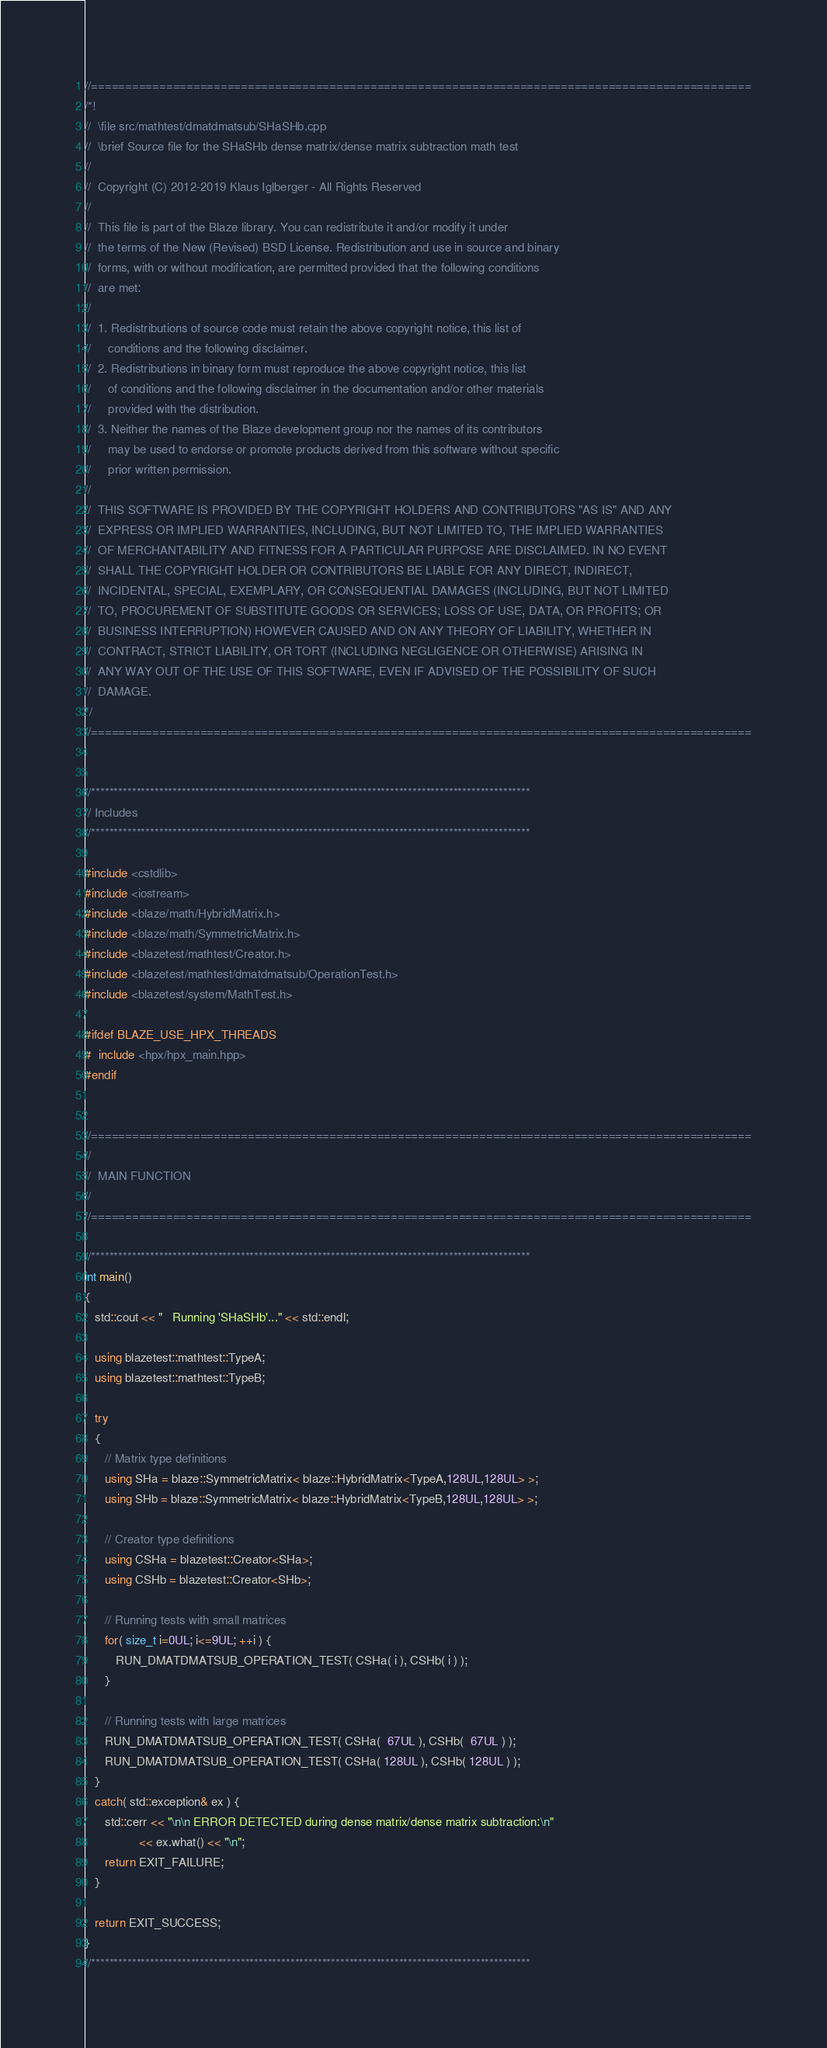Convert code to text. <code><loc_0><loc_0><loc_500><loc_500><_C++_>//=================================================================================================
/*!
//  \file src/mathtest/dmatdmatsub/SHaSHb.cpp
//  \brief Source file for the SHaSHb dense matrix/dense matrix subtraction math test
//
//  Copyright (C) 2012-2019 Klaus Iglberger - All Rights Reserved
//
//  This file is part of the Blaze library. You can redistribute it and/or modify it under
//  the terms of the New (Revised) BSD License. Redistribution and use in source and binary
//  forms, with or without modification, are permitted provided that the following conditions
//  are met:
//
//  1. Redistributions of source code must retain the above copyright notice, this list of
//     conditions and the following disclaimer.
//  2. Redistributions in binary form must reproduce the above copyright notice, this list
//     of conditions and the following disclaimer in the documentation and/or other materials
//     provided with the distribution.
//  3. Neither the names of the Blaze development group nor the names of its contributors
//     may be used to endorse or promote products derived from this software without specific
//     prior written permission.
//
//  THIS SOFTWARE IS PROVIDED BY THE COPYRIGHT HOLDERS AND CONTRIBUTORS "AS IS" AND ANY
//  EXPRESS OR IMPLIED WARRANTIES, INCLUDING, BUT NOT LIMITED TO, THE IMPLIED WARRANTIES
//  OF MERCHANTABILITY AND FITNESS FOR A PARTICULAR PURPOSE ARE DISCLAIMED. IN NO EVENT
//  SHALL THE COPYRIGHT HOLDER OR CONTRIBUTORS BE LIABLE FOR ANY DIRECT, INDIRECT,
//  INCIDENTAL, SPECIAL, EXEMPLARY, OR CONSEQUENTIAL DAMAGES (INCLUDING, BUT NOT LIMITED
//  TO, PROCUREMENT OF SUBSTITUTE GOODS OR SERVICES; LOSS OF USE, DATA, OR PROFITS; OR
//  BUSINESS INTERRUPTION) HOWEVER CAUSED AND ON ANY THEORY OF LIABILITY, WHETHER IN
//  CONTRACT, STRICT LIABILITY, OR TORT (INCLUDING NEGLIGENCE OR OTHERWISE) ARISING IN
//  ANY WAY OUT OF THE USE OF THIS SOFTWARE, EVEN IF ADVISED OF THE POSSIBILITY OF SUCH
//  DAMAGE.
*/
//=================================================================================================


//*************************************************************************************************
// Includes
//*************************************************************************************************

#include <cstdlib>
#include <iostream>
#include <blaze/math/HybridMatrix.h>
#include <blaze/math/SymmetricMatrix.h>
#include <blazetest/mathtest/Creator.h>
#include <blazetest/mathtest/dmatdmatsub/OperationTest.h>
#include <blazetest/system/MathTest.h>

#ifdef BLAZE_USE_HPX_THREADS
#  include <hpx/hpx_main.hpp>
#endif


//=================================================================================================
//
//  MAIN FUNCTION
//
//=================================================================================================

//*************************************************************************************************
int main()
{
   std::cout << "   Running 'SHaSHb'..." << std::endl;

   using blazetest::mathtest::TypeA;
   using blazetest::mathtest::TypeB;

   try
   {
      // Matrix type definitions
      using SHa = blaze::SymmetricMatrix< blaze::HybridMatrix<TypeA,128UL,128UL> >;
      using SHb = blaze::SymmetricMatrix< blaze::HybridMatrix<TypeB,128UL,128UL> >;

      // Creator type definitions
      using CSHa = blazetest::Creator<SHa>;
      using CSHb = blazetest::Creator<SHb>;

      // Running tests with small matrices
      for( size_t i=0UL; i<=9UL; ++i ) {
         RUN_DMATDMATSUB_OPERATION_TEST( CSHa( i ), CSHb( i ) );
      }

      // Running tests with large matrices
      RUN_DMATDMATSUB_OPERATION_TEST( CSHa(  67UL ), CSHb(  67UL ) );
      RUN_DMATDMATSUB_OPERATION_TEST( CSHa( 128UL ), CSHb( 128UL ) );
   }
   catch( std::exception& ex ) {
      std::cerr << "\n\n ERROR DETECTED during dense matrix/dense matrix subtraction:\n"
                << ex.what() << "\n";
      return EXIT_FAILURE;
   }

   return EXIT_SUCCESS;
}
//*************************************************************************************************
</code> 